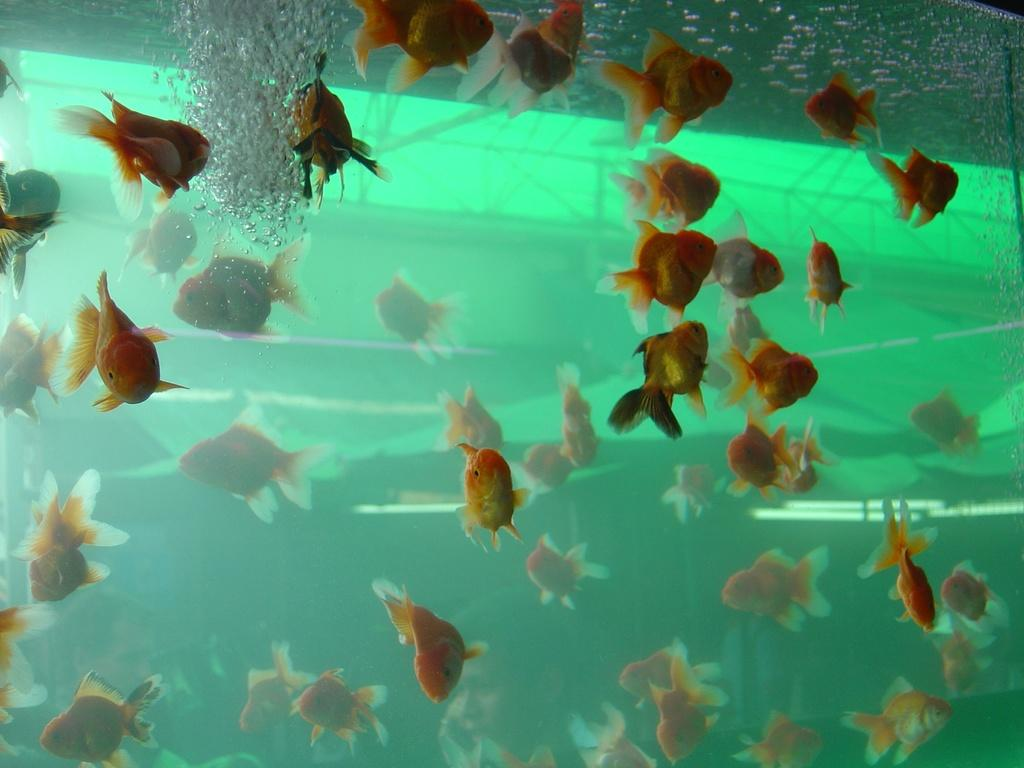What is the main feature of the image? There is an aquarium in the image. What can be found inside the aquarium? There are fishes in the aquarium. What type of pipe is visible in the image? There is no pipe present in the image; it features an aquarium with fishes. 